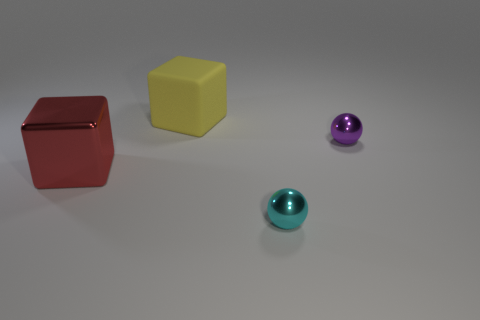What different shapes are present in this image? In this image, we have a representation of a few basic shapes: there are two cubes and two spheres. The diversity in shapes provides a simple yet effective study in geometry. 